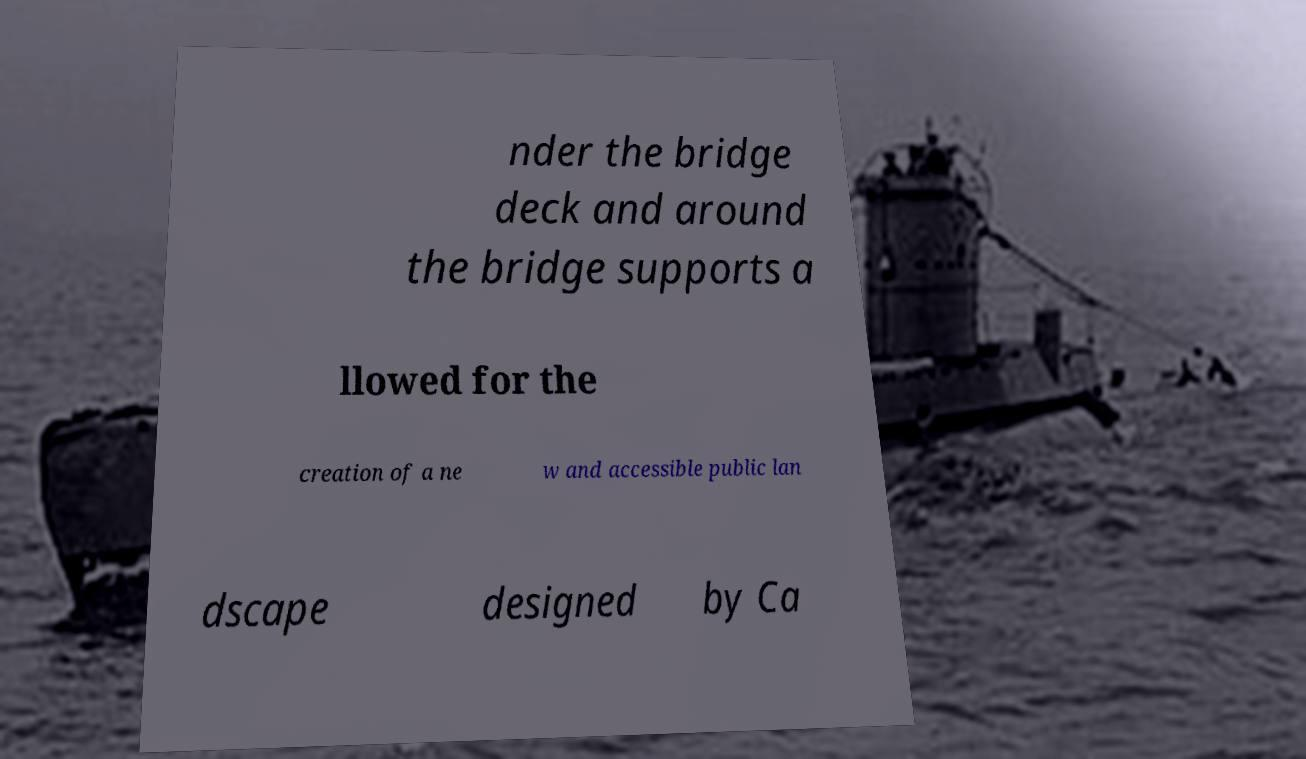For documentation purposes, I need the text within this image transcribed. Could you provide that? nder the bridge deck and around the bridge supports a llowed for the creation of a ne w and accessible public lan dscape designed by Ca 